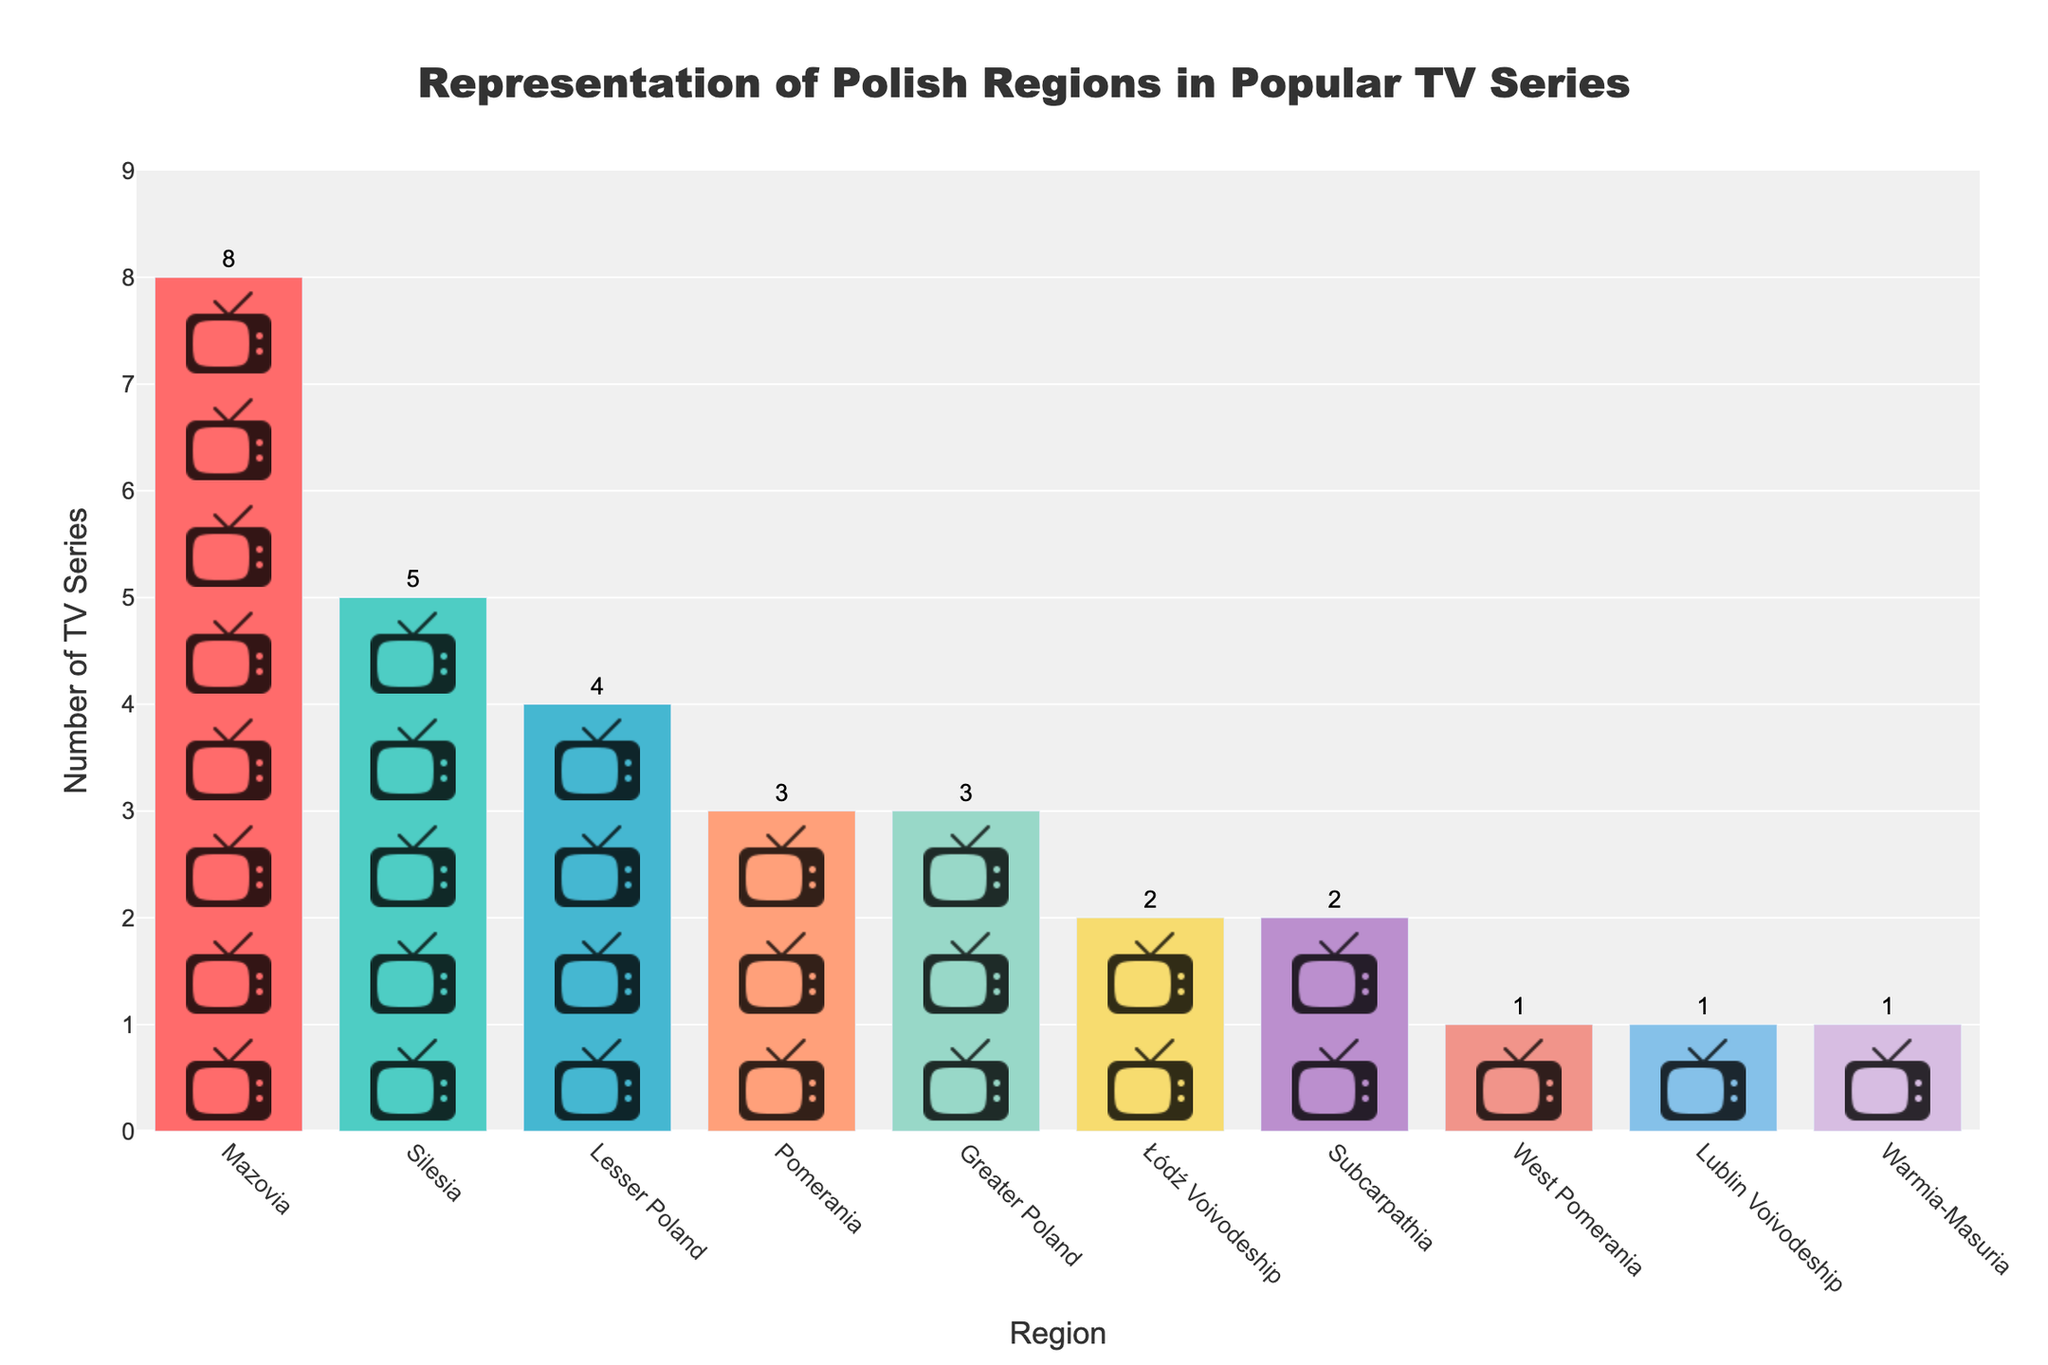What's the title of the figure? The title is displayed prominently at the top of the figure. It reads "Representation of Polish Regions in Popular TV Series".
Answer: Representation of Polish Regions in Popular TV Series Which region has the highest series count? By examining the height of the bars, the Mazovia region has the tallest bar, indicating the highest series count.
Answer: Mazovia How many TV series are set in Greater Poland? The data label positioned at the top of the bar for Greater Poland shows the number "3".
Answer: 3 What is the total number of TV series depicted in the figure? Adding up all the series counts from each bar: 8 (Mazovia) + 5 (Silesia) + 4 (Lesser Poland) + 3 (Pomerania) + 3 (Greater Poland) + 2 (Łódź Voivodeship) + 2 (Subcarpathia) + 1 (West Pomerania) + 1 (Lublin Voivodeship) + 1 (Warmia-Masuria) = 30.
Answer: 30 Which regions have the same number of TV series? Comparing the heights of the bars, the Pomerania and Greater Poland regions both have bars labeled with "3". Additionally, Łódź Voivodeship and Subcarpathia both have "2", while West Pomerania, Lublin Voivodeship, and Warmia-Masuria each have "1".
Answer: Pomerania, Greater Poland; Łódź Voivodeship, Subcarpathia; West Pomerania, Lublin Voivodeship, Warmia-Masuria What is the difference in series count between Mazovia and Silesia? The series count for Mazovia is 8, and for Silesia, it is 5. Calculating the difference: 8 - 5 = 3.
Answer: 3 Rank the regions from highest to lowest based on their series count. By arranging the regions according to their series counts: Mazovia (8), Silesia (5), Lesser Poland (4), Pomerania (3), Greater Poland (3), Łódź Voivodeship (2), Subcarpathia (2), West Pomerania (1), Lublin Voivodeship (1), Warmia-Masuria (1).
Answer: Mazovia, Silesia, Lesser Poland, Pomerania, Greater Poland, Łódź Voivodeship, Subcarpathia, West Pomerania, Lublin Voivodeship, Warmia-Masuria How many regions have a series count of 1? The bars with the height "1" correspond to West Pomerania, Lublin Voivodeship, and Warmia-Masuria. Counting these regions: 3 regions.
Answer: 3 Which regions have fewer than 3 TV series? By checking the bars whose values are less than 3: Łódź Voivodeship (2), Subcarpathia (2), West Pomerania (1), Lublin Voivodeship (1), Warmia-Masuria (1).
Answer: Łódź Voivodeship, Subcarpathia, West Pomerania, Lublin Voivodeship, Warmia-Masuria 